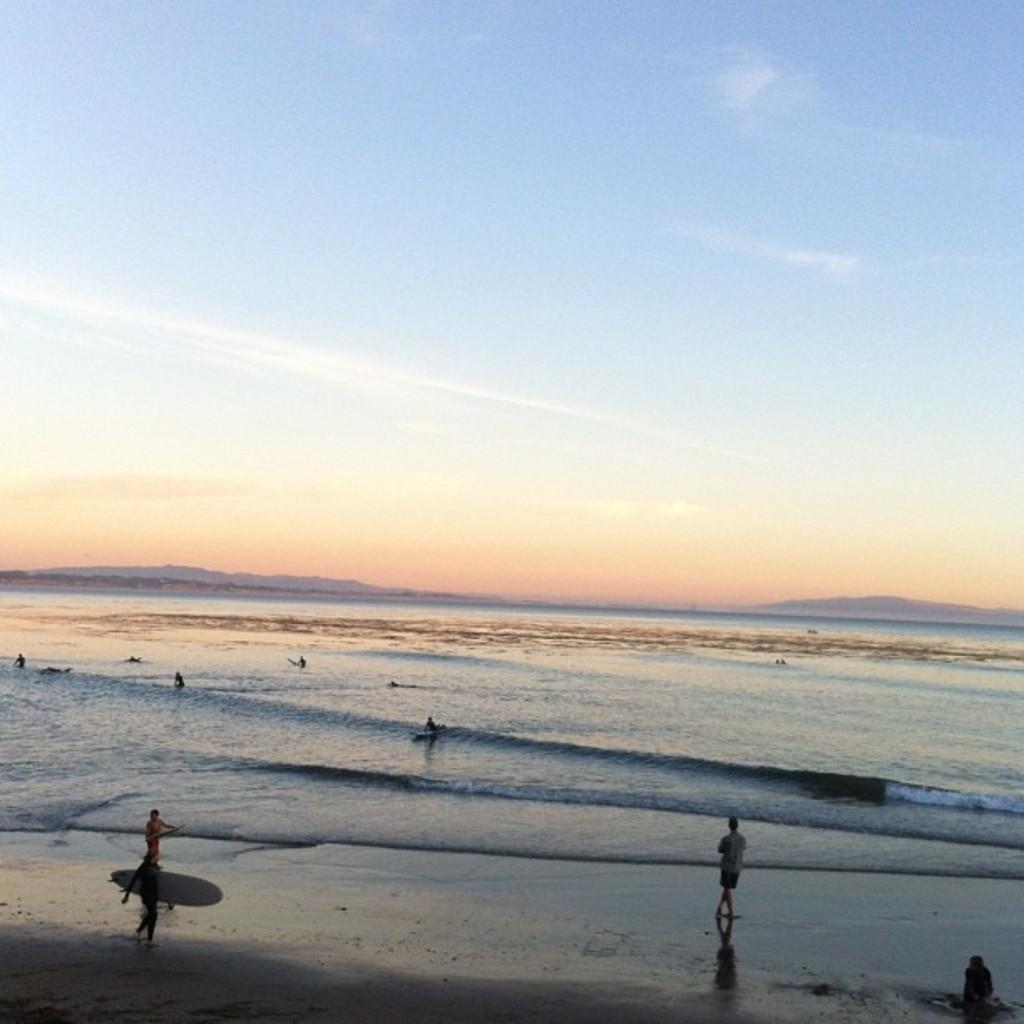Could you give a brief overview of what you see in this image? In this picture we can see the view of the seaside. In front there a boy standing and someone walking on sea sand holding surfing board. Behind we can see water waves and some mountains. 